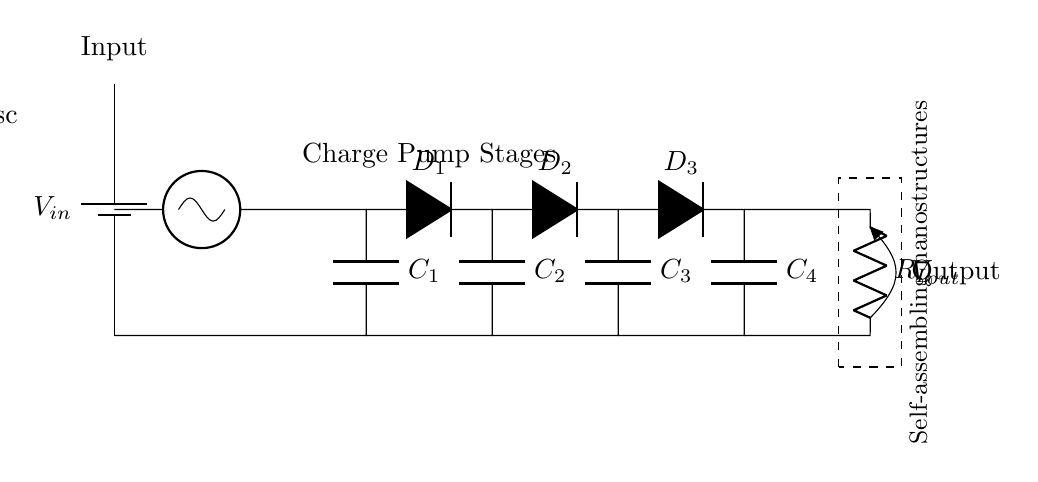What is the input component of this circuit? The input component is a battery, which is labeled as V_in in the circuit diagram, providing the necessary voltage for the circuit to operate.
Answer: battery How many capacitors are present in the circuit? There are four capacitors in the circuit, labeled as C_1, C_2, C_3, and C_4; they are connected in conjunction with the diodes for charge pumping.
Answer: four Which component is responsible for regulating the output voltage? The output voltage is regulated by the load resistor labeled R_L, which helps to manage the flow of current to the nanostructure load.
Answer: R_L What is the main function of the oscillator? The oscillator generates alternating current that is necessary for charging the capacitors and driving the operation of the charge pump circuit.
Answer: charge generation How does the circuit convert input voltage to output voltage? The circuit utilizes a series of capacitors and diodes to step up the input voltage through charge pumping, where capacitors are charged and then discharged to increase voltage at the output.
Answer: charge pumping What is the significance of the dashed rectangle in the diagram? The dashed rectangle represents the self-assembling nanostructures, indicating the load that the circuit is designed to power, which is a critical component of nanotechnology applications.
Answer: nanostructures What direction do the diodes in the circuit face? The diodes face in a direction that allows current to flow toward the capacitors and eventually to the load, ensuring that the charge is stored and moved efficiently.
Answer: forward 